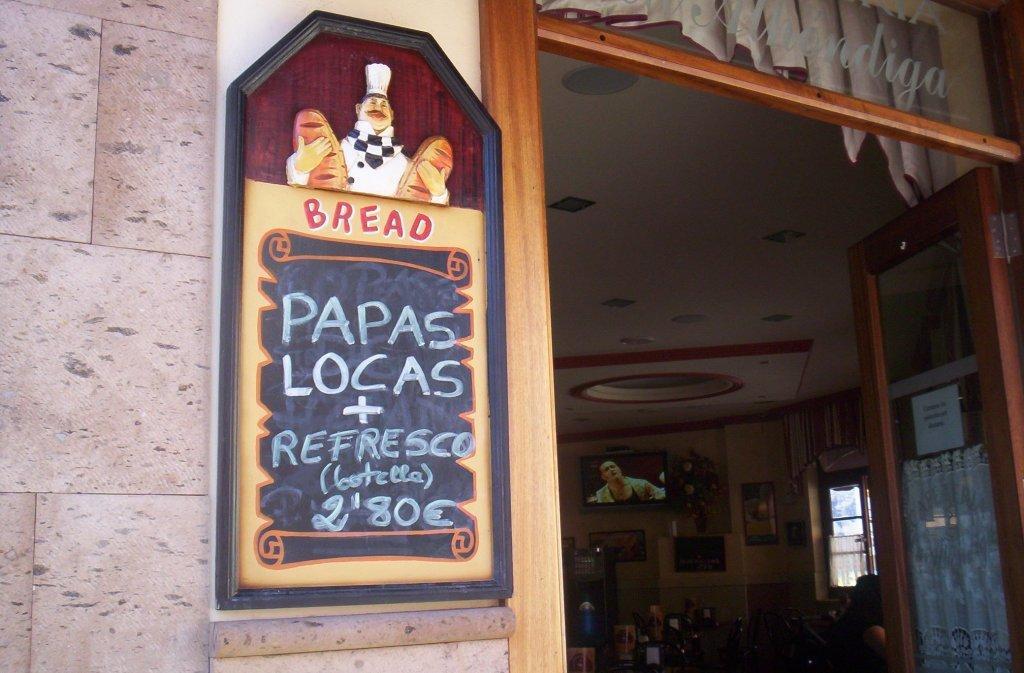How would you summarize this image in a sentence or two? On the left side of the image there is a wall with a frame. On the frame, we can see some text and one person is holding some objects. In the background there is a wall, window, monitor, door, one person, curtains and a few other objects. 